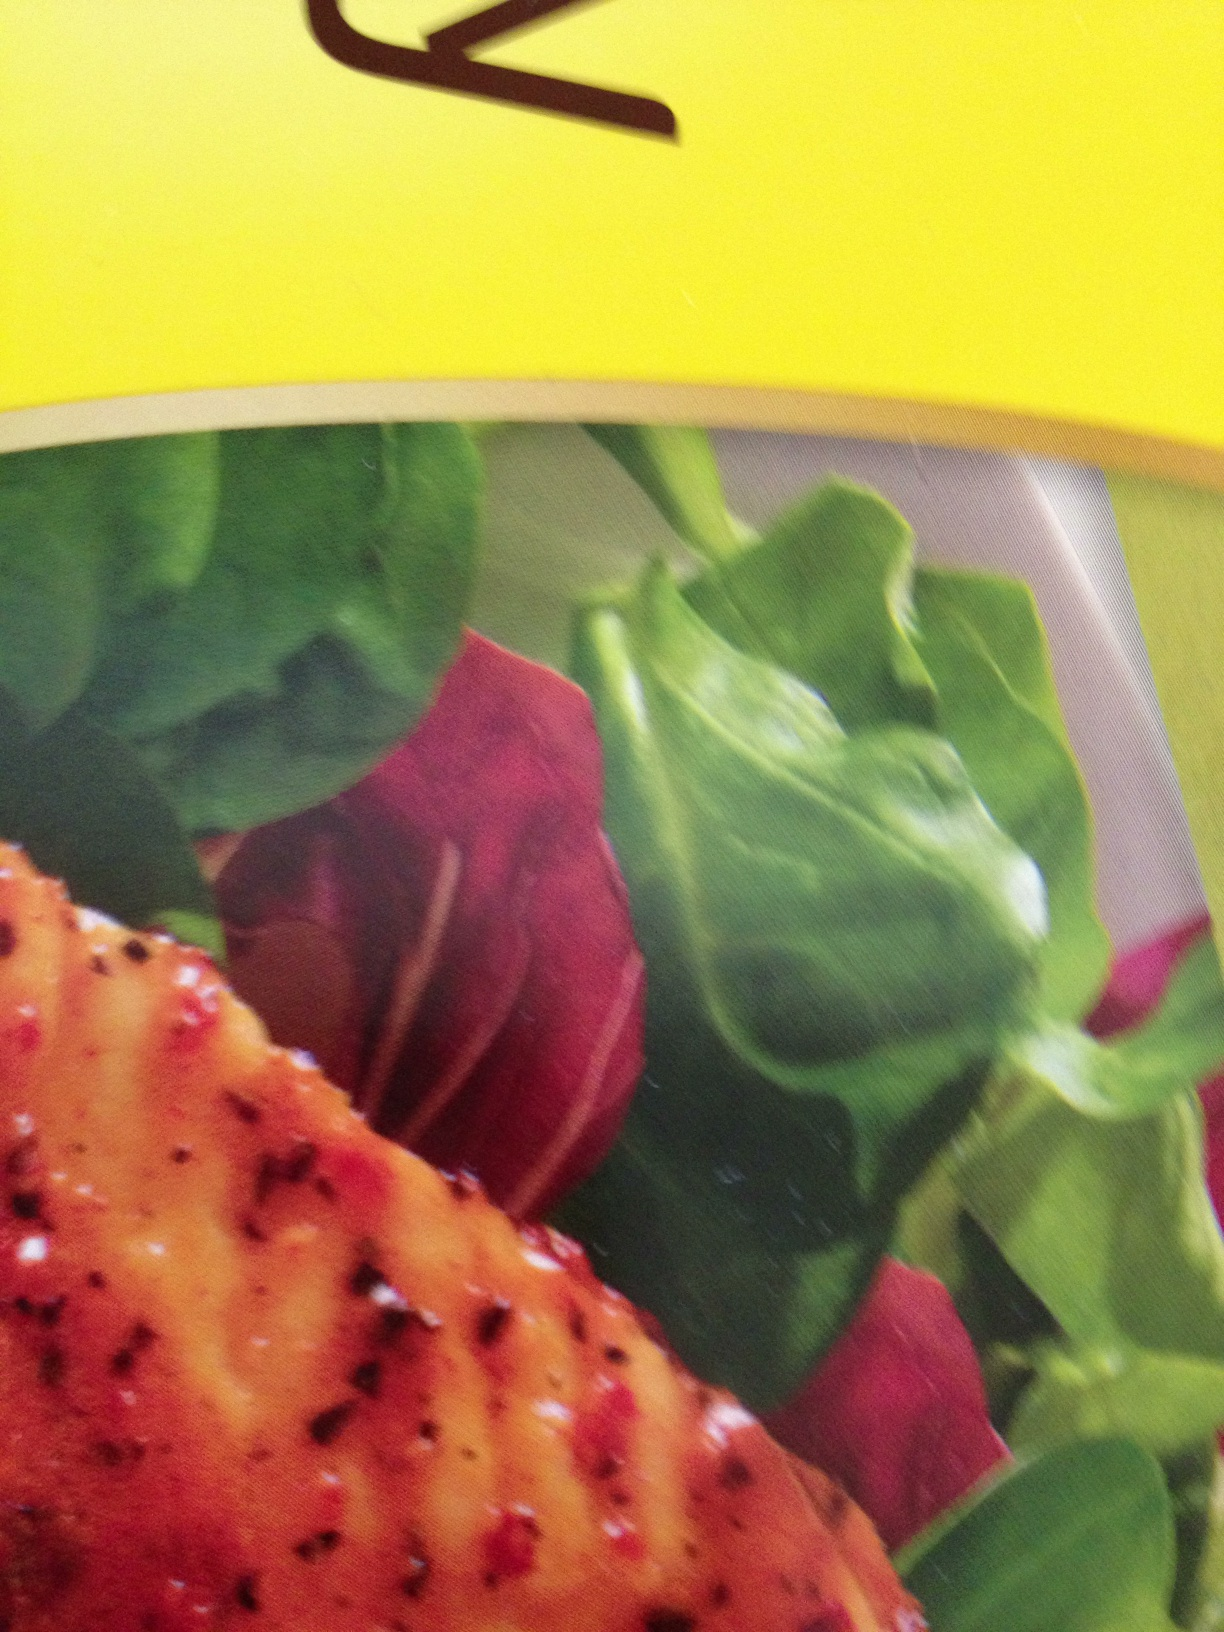Imagine you are the chef who created this dish. Can you explain the inspiration behind it? As the chef who created this dish, I was inspired by a blend of vibrant, fresh ingredients and hearty, seasoned proteins. The grilled meat is carefully marinated to bring out savory flavors, while the fresh greens and red beet slices add a balance of earthy, sweet, and slightly bitter notes. My goal was to create a nutritious yet delicious plate, appealing both in taste and aesthetics. 